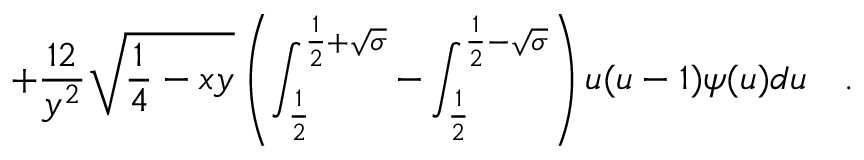Convert formula to latex. <formula><loc_0><loc_0><loc_500><loc_500>+ { \frac { 1 2 } { y ^ { 2 } } } \sqrt { { \frac { 1 } { 4 } } - x y } \left ( \int _ { \frac { 1 } { 2 } } ^ { \frac { 1 } { 2 } + \sqrt { \sigma } } - \int _ { \frac { 1 } { 2 } } ^ { \frac { 1 } { 2 } - \sqrt { \sigma } } \right ) u ( u - 1 ) \psi ( u ) d u .</formula> 